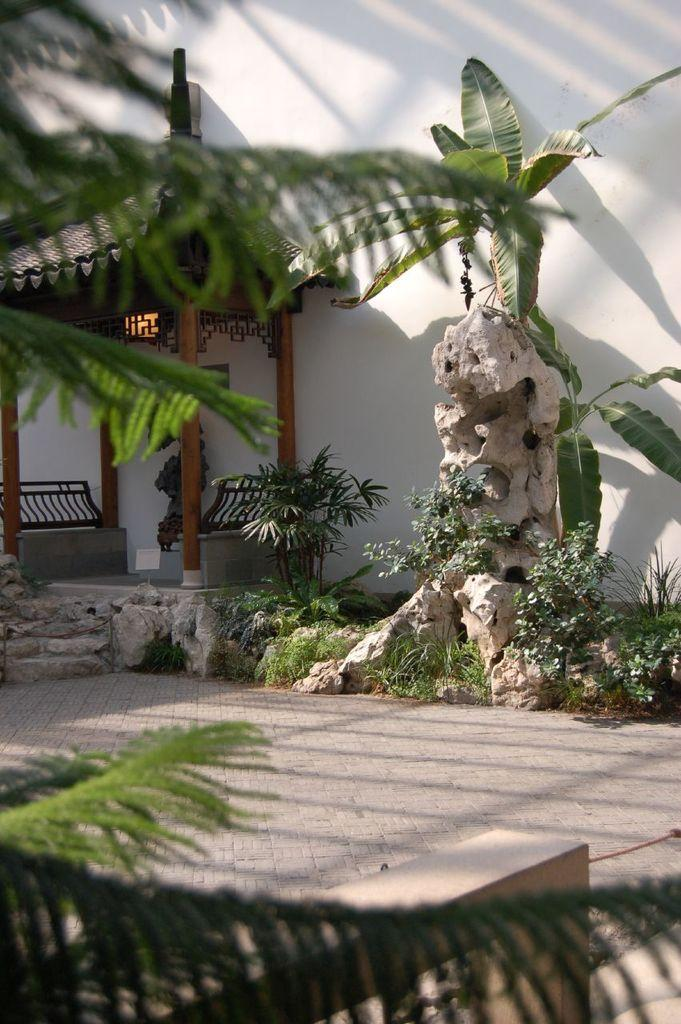What type of structure can be seen in the image? There is a small hut in the image. What natural elements are present in the image? There are trees and plants in the image. What type of seating is available in the image? There are two benches in the image. What is the background of the image? The background of the image includes a wall. What shape is the rain forming in the image? There is no rain present in the image, so it is not possible to determine the shape of any raindrops. 